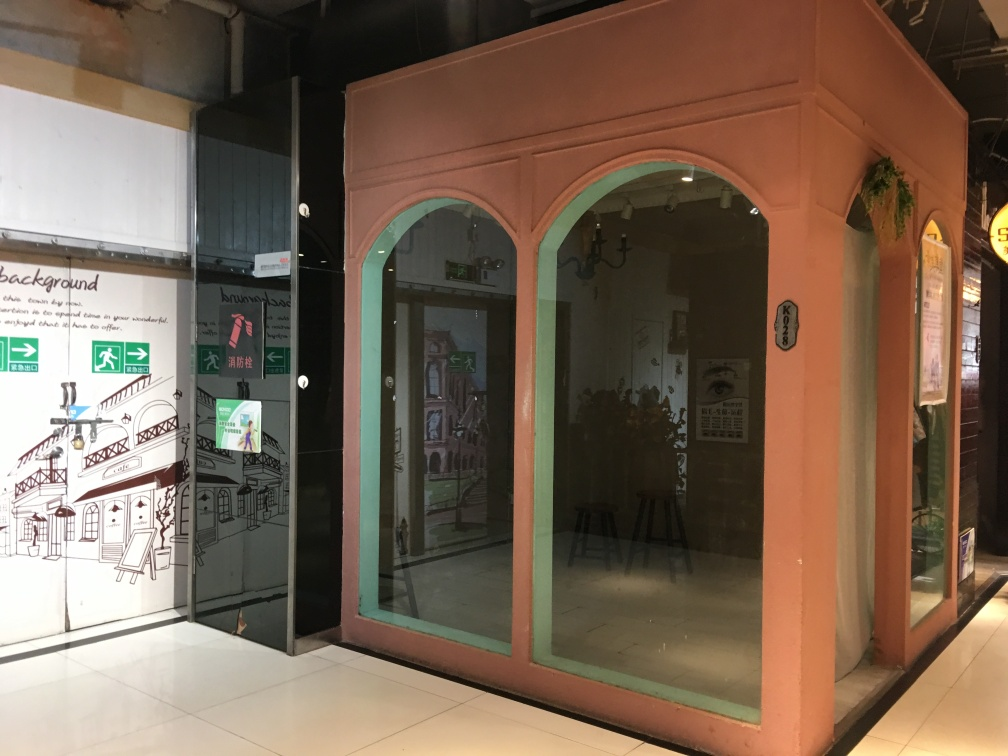Could you tell me more about the theme or style of the architecture depicted on the wall? The artwork on the wall seems to depict a variety of architectural structures, giving a sense of a historical or cultural area. It features bridges, buildings, and elements that might be found in an older part of a town, possibly indicating a place with rich heritage. The style is somewhat whimsical and illustrative, suggesting that it might be part of a larger storytelling exhibit or cultural presentation. 